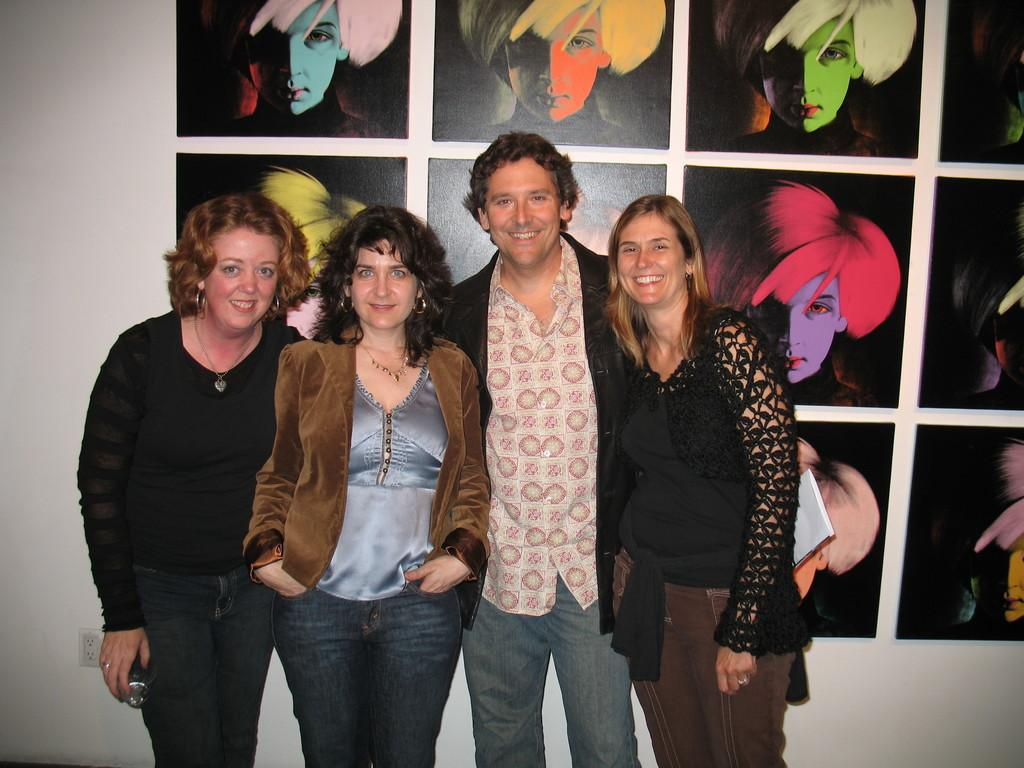What are the people in the image doing? The people in the image are standing and smiling. What can be seen on the wall behind the people? There is a white wall visible in the image, and there are pictures of faces on the white wall. What type of nail is being used to hang the ornament on the wall in the image? There is no ornament or nail present in the image; only the people and the pictures of faces on the white wall are visible. 